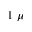Convert formula to latex. <formula><loc_0><loc_0><loc_500><loc_500>1 \ \mu</formula> 